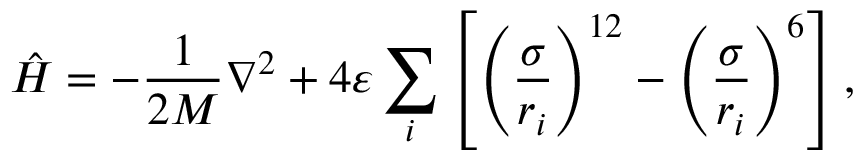<formula> <loc_0><loc_0><loc_500><loc_500>\hat { H } = - \frac { 1 } { 2 M } \nabla ^ { 2 } + 4 \varepsilon \sum _ { i } \left [ \left ( \frac { \sigma } { r _ { i } } \right ) ^ { 1 2 } - \left ( \frac { \sigma } { r _ { i } } \right ) ^ { 6 } \right ] ,</formula> 